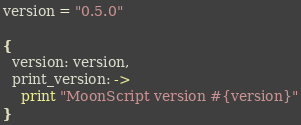<code> <loc_0><loc_0><loc_500><loc_500><_MoonScript_>
version = "0.5.0"

{
  version: version,
  print_version: ->
    print "MoonScript version #{version}"
}
</code> 